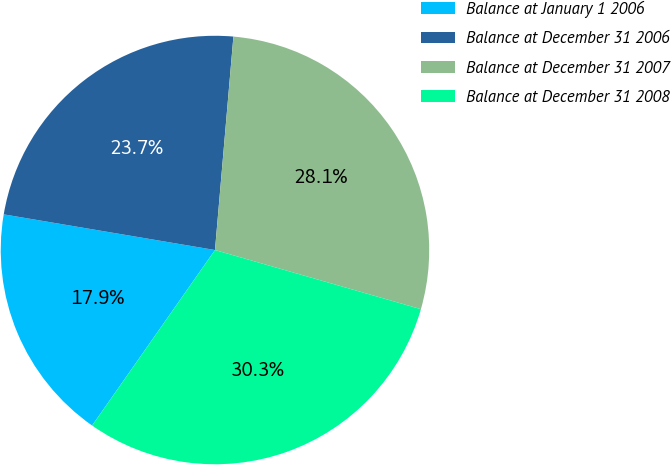<chart> <loc_0><loc_0><loc_500><loc_500><pie_chart><fcel>Balance at January 1 2006<fcel>Balance at December 31 2006<fcel>Balance at December 31 2007<fcel>Balance at December 31 2008<nl><fcel>17.94%<fcel>23.71%<fcel>28.08%<fcel>30.27%<nl></chart> 